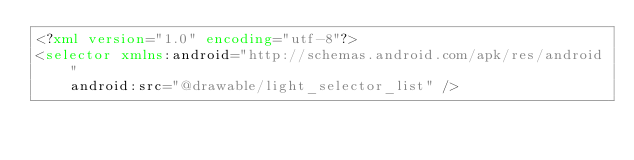Convert code to text. <code><loc_0><loc_0><loc_500><loc_500><_XML_><?xml version="1.0" encoding="utf-8"?>
<selector xmlns:android="http://schemas.android.com/apk/res/android"
    android:src="@drawable/light_selector_list" /></code> 